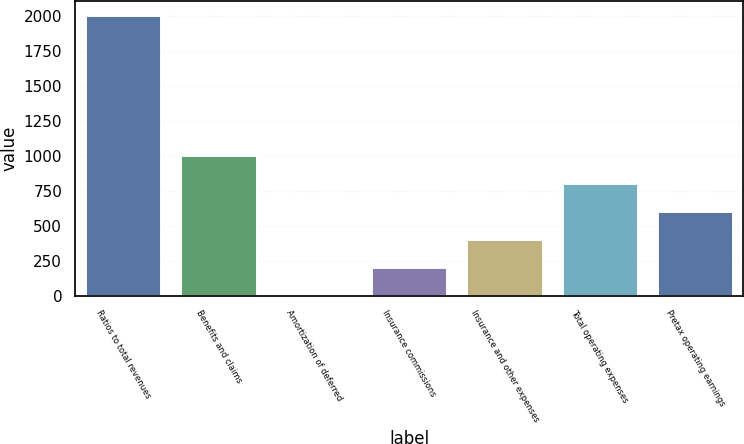Convert chart to OTSL. <chart><loc_0><loc_0><loc_500><loc_500><bar_chart><fcel>Ratios to total revenues<fcel>Benefits and claims<fcel>Amortization of deferred<fcel>Insurance commissions<fcel>Insurance and other expenses<fcel>Total operating expenses<fcel>Pretax operating earnings<nl><fcel>2008<fcel>1007.85<fcel>7.7<fcel>207.73<fcel>407.76<fcel>807.82<fcel>607.79<nl></chart> 